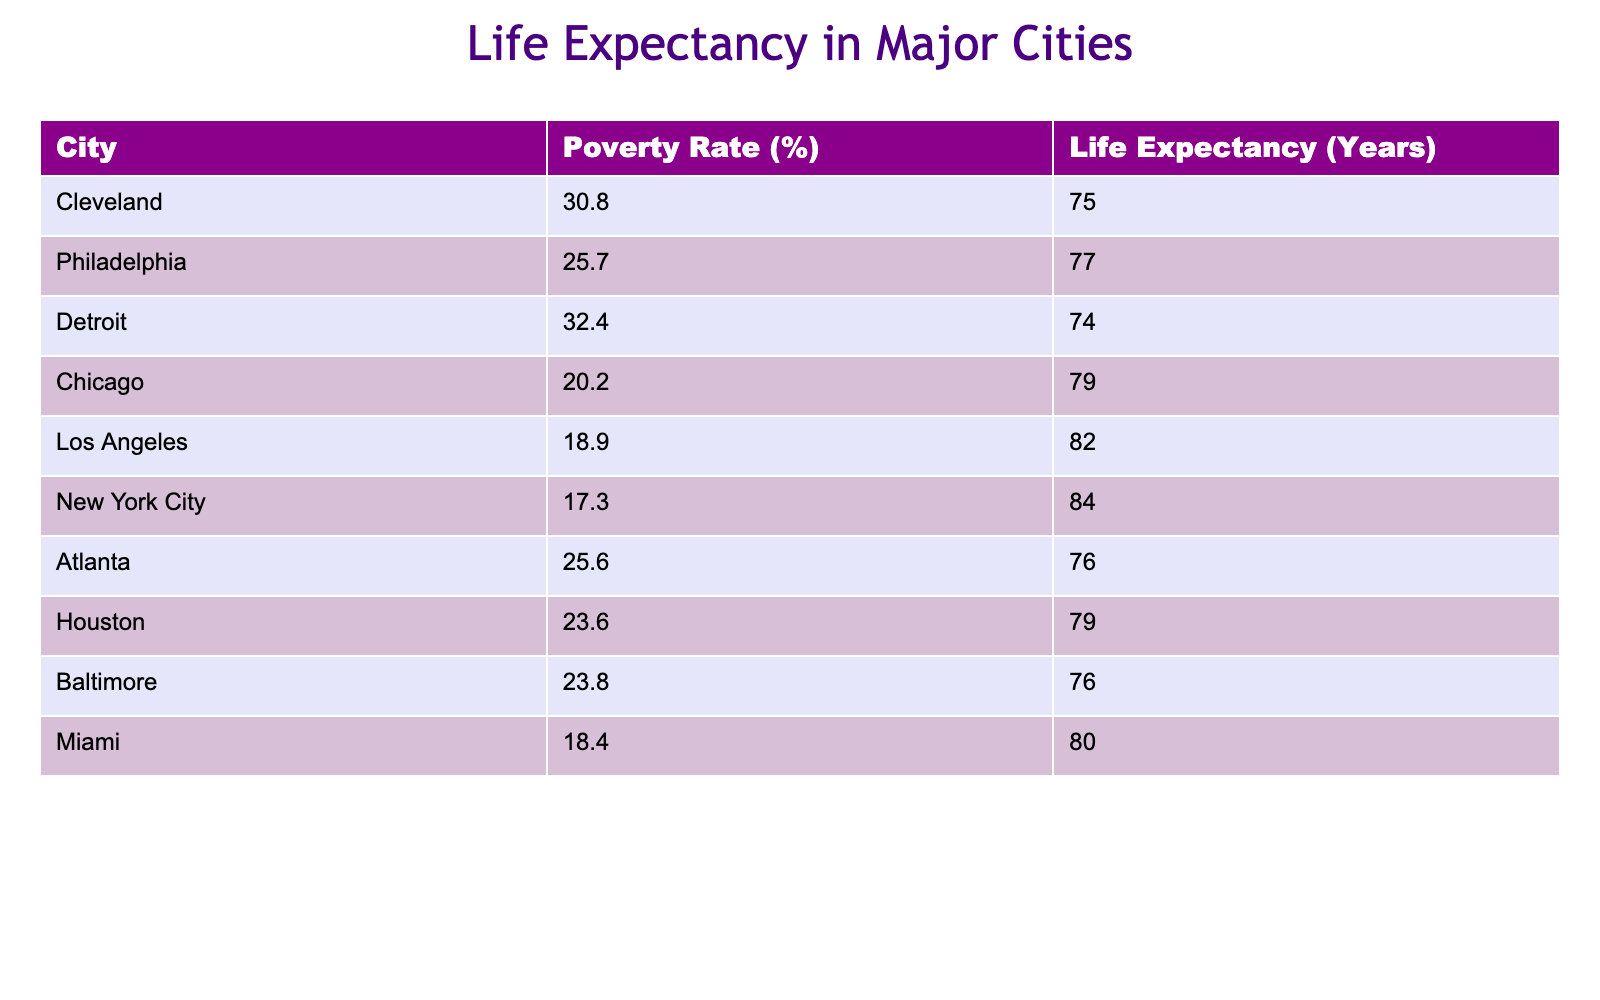What city has the highest life expectancy? By reviewing the table, we look for the city with the maximum value under the "Life Expectancy" column. New York City shows the highest life expectancy at 84 years.
Answer: New York City What is the poverty rate of Chicago? The table includes the "Poverty Rate" column where we can find the entry for Chicago, which is clearly indicated as 20.2%.
Answer: 20.2% Is the life expectancy in Detroit higher than in Atlanta? To answer this question, we need to compare the "Life Expectancy" values for both cities. Detroit's life expectancy is 74 years while Atlanta's is 76 years, so Detroit has a lower life expectancy.
Answer: No What is the average poverty rate of the cities listed in the table? We sum up the poverty rates for all cities: (30.8 + 25.7 + 32.4 + 20.2 + 18.9 + 17.3 + 25.6 + 23.6 + 23.8 + 18.4) =  266.7. Then, dividing by the total number of cities (10), we get an average of 26.67%.
Answer: 26.67% Which city has a life expectancy of 75 years? We check the "Life Expectancy" column for the value of 75 years and find that Cleveland fits this criterion.
Answer: Cleveland What is the difference in life expectancy between the city with the highest and lowest poverty rates? The highest poverty rate is in Detroit at 32.4%, and it has a life expectancy of 74 years. The lowest poverty rate is in New York City at 17.3%, with a life expectancy of 84 years. The difference in life expectancy is 84 - 74 = 10 years.
Answer: 10 years Is the poverty rate in Miami lower than in Philadelphia? By directly comparing the "Poverty Rate" values, we see Miami has a poverty rate of 18.4% while Philadelphia has a rate of 25.7%. Thus, Miami's poverty rate is lower.
Answer: Yes What city experiences a life expectancy of 76 years while having a poverty rate below 25%? Checking the table, we see that Atlanta has a life expectancy of 76 years and a poverty rate of 25.6%, while no cities listed meet the criteria for below 25%. Hence, we conclude that no city fits this condition.
Answer: No 